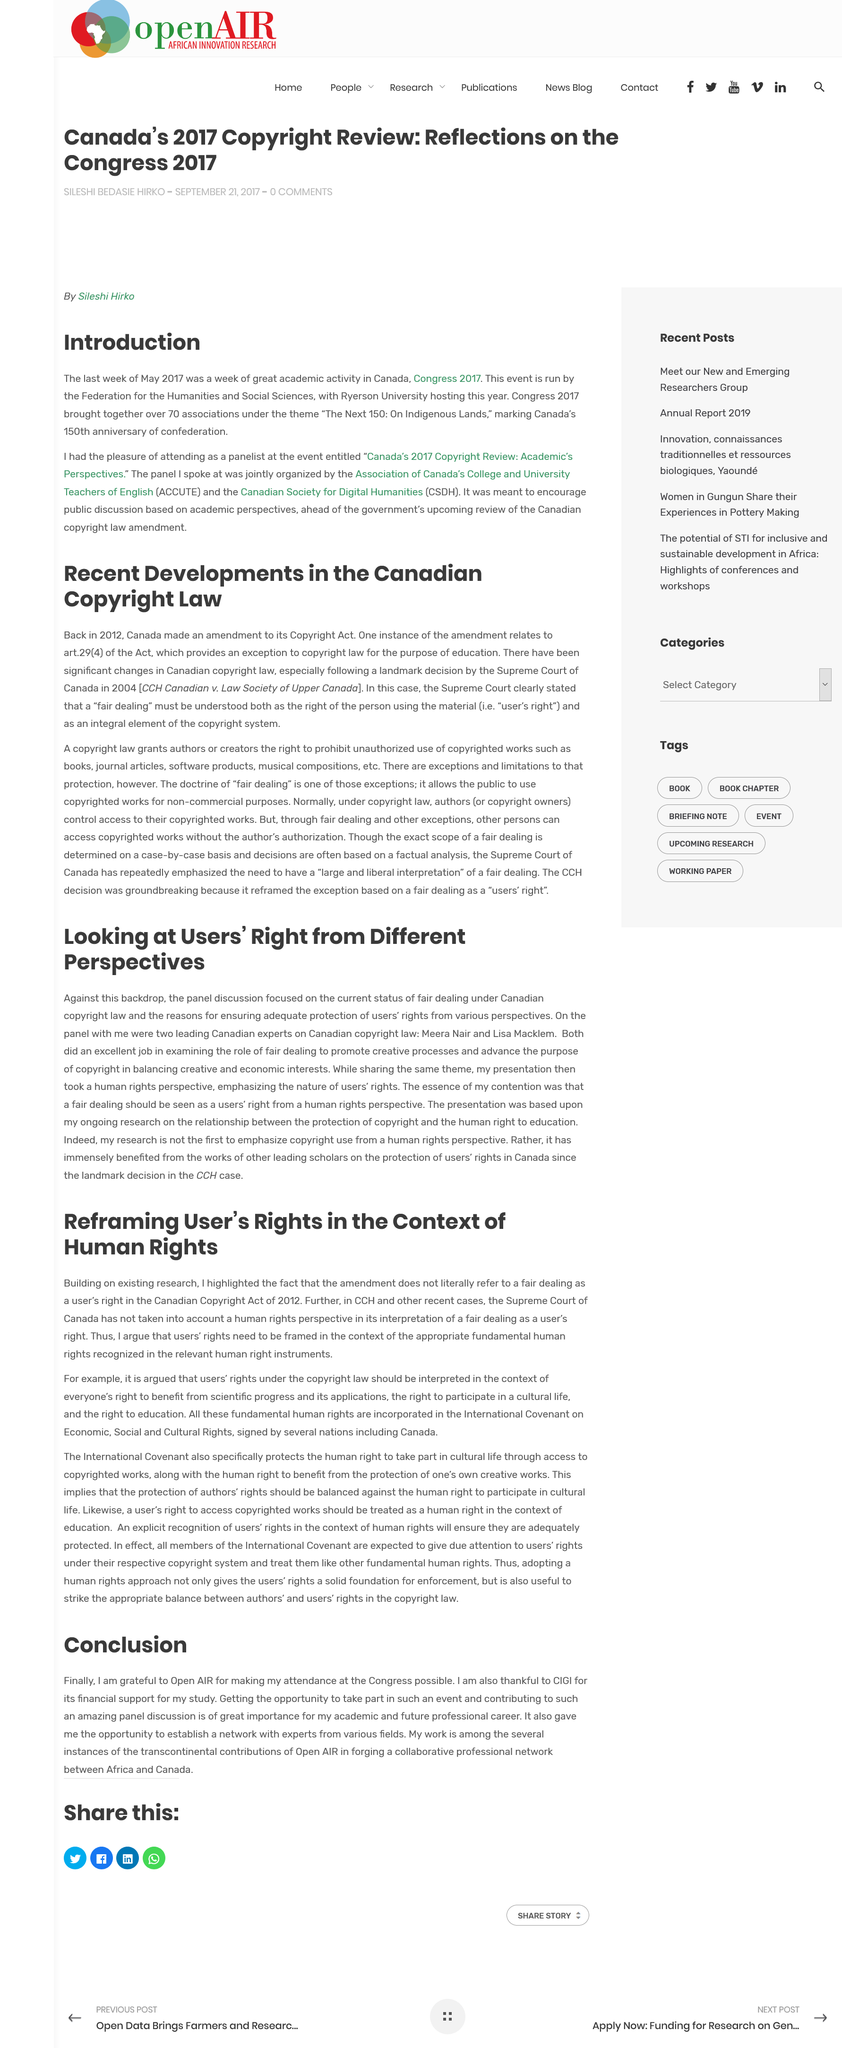Highlight a few significant elements in this photo. The answer is yes. Art can be utilized as a tool for education. The Canadian Copyright Act was published in 2012. The Supreme Court of Canada has not taken into account a human rights perspective in its interpretation of fair dealing as a user's right in CCH and other recent cases. The author of the text is grateful to Open AIR. 